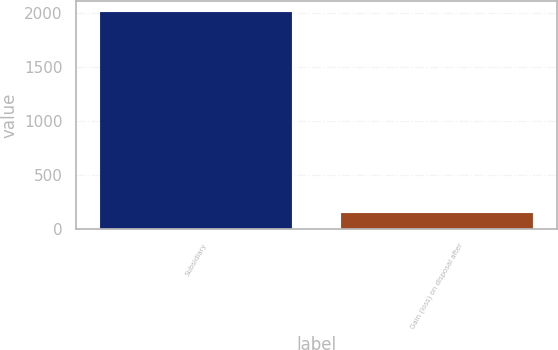<chart> <loc_0><loc_0><loc_500><loc_500><bar_chart><fcel>Subsidiary<fcel>Gain (loss) on disposal after<nl><fcel>2009<fcel>150<nl></chart> 